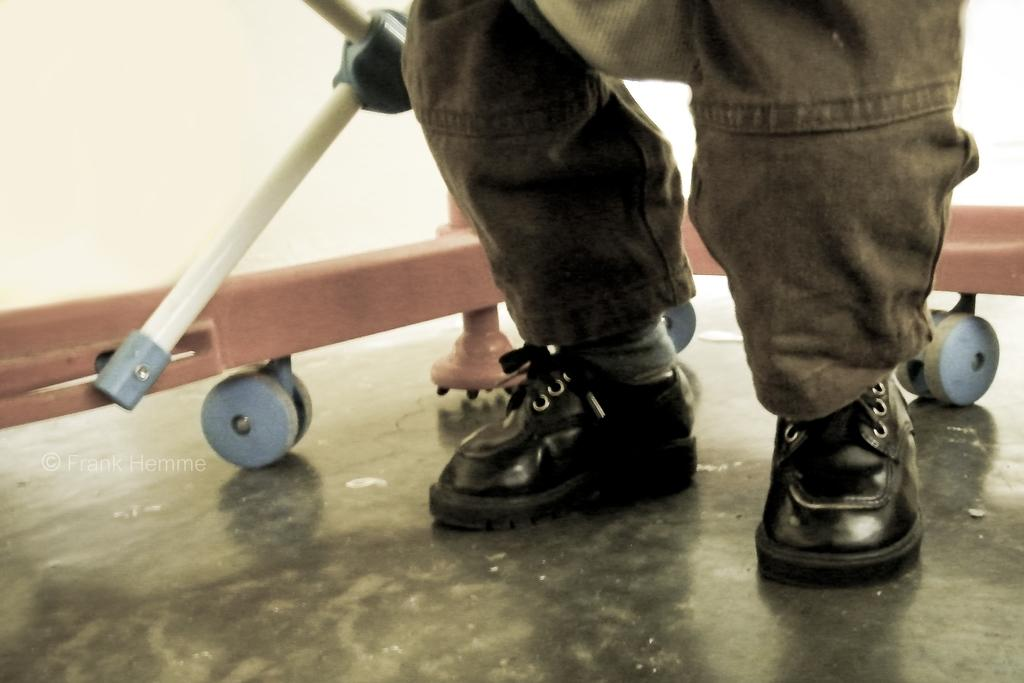What can be seen at the bottom of the image? There are legs of a person with shoes in the image. What is located behind the legs in the image? There are rods with wheels behind the legs. What color is the background of the image? The background of the image is white. What type of creature can be smelled in the image? There is no creature present in the image, and therefore no smell can be associated with it. 